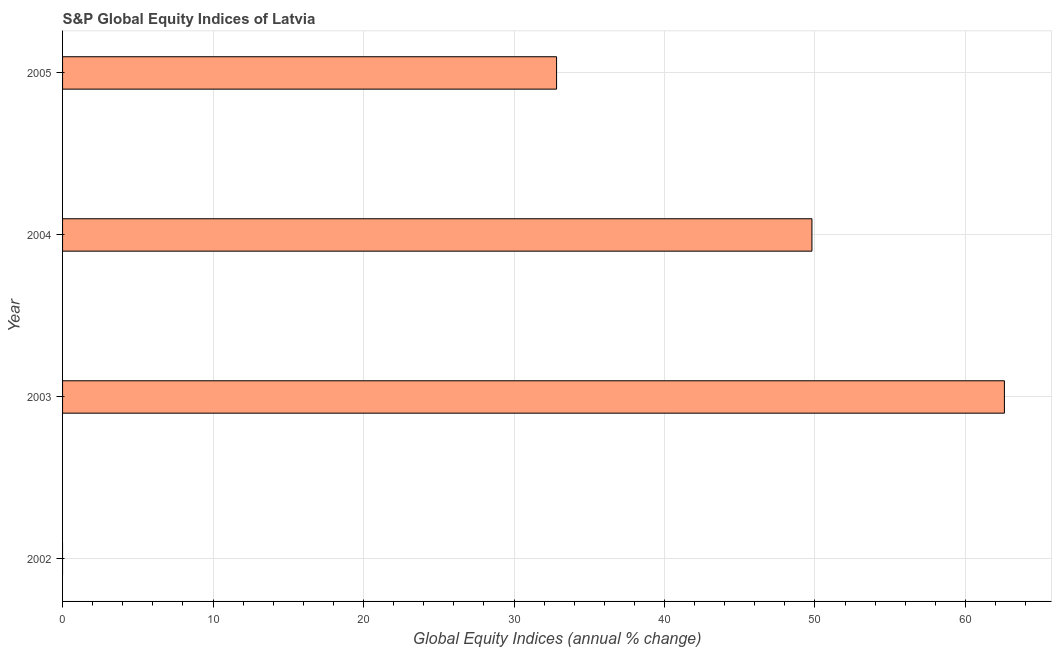Does the graph contain any zero values?
Offer a terse response. Yes. Does the graph contain grids?
Make the answer very short. Yes. What is the title of the graph?
Ensure brevity in your answer.  S&P Global Equity Indices of Latvia. What is the label or title of the X-axis?
Your answer should be compact. Global Equity Indices (annual % change). What is the label or title of the Y-axis?
Offer a very short reply. Year. Across all years, what is the maximum s&p global equity indices?
Provide a short and direct response. 62.59. In which year was the s&p global equity indices maximum?
Ensure brevity in your answer.  2003. What is the sum of the s&p global equity indices?
Make the answer very short. 145.22. What is the difference between the s&p global equity indices in 2004 and 2005?
Your answer should be very brief. 16.97. What is the average s&p global equity indices per year?
Offer a very short reply. 36.3. What is the median s&p global equity indices?
Keep it short and to the point. 41.31. What is the ratio of the s&p global equity indices in 2003 to that in 2004?
Make the answer very short. 1.26. Is the s&p global equity indices in 2003 less than that in 2005?
Ensure brevity in your answer.  No. What is the difference between the highest and the second highest s&p global equity indices?
Keep it short and to the point. 12.79. Is the sum of the s&p global equity indices in 2004 and 2005 greater than the maximum s&p global equity indices across all years?
Give a very brief answer. Yes. What is the difference between the highest and the lowest s&p global equity indices?
Your answer should be very brief. 62.59. How many years are there in the graph?
Your response must be concise. 4. What is the difference between two consecutive major ticks on the X-axis?
Make the answer very short. 10. What is the Global Equity Indices (annual % change) in 2003?
Keep it short and to the point. 62.59. What is the Global Equity Indices (annual % change) in 2004?
Make the answer very short. 49.8. What is the Global Equity Indices (annual % change) of 2005?
Provide a short and direct response. 32.83. What is the difference between the Global Equity Indices (annual % change) in 2003 and 2004?
Provide a succinct answer. 12.79. What is the difference between the Global Equity Indices (annual % change) in 2003 and 2005?
Your response must be concise. 29.76. What is the difference between the Global Equity Indices (annual % change) in 2004 and 2005?
Offer a terse response. 16.97. What is the ratio of the Global Equity Indices (annual % change) in 2003 to that in 2004?
Provide a succinct answer. 1.26. What is the ratio of the Global Equity Indices (annual % change) in 2003 to that in 2005?
Provide a short and direct response. 1.91. What is the ratio of the Global Equity Indices (annual % change) in 2004 to that in 2005?
Offer a very short reply. 1.52. 